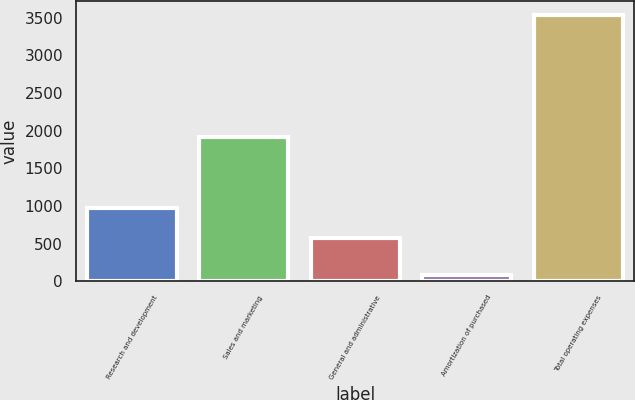Convert chart to OTSL. <chart><loc_0><loc_0><loc_500><loc_500><bar_chart><fcel>Research and development<fcel>Sales and marketing<fcel>General and administrative<fcel>Amortization of purchased<fcel>Total operating expenses<nl><fcel>976<fcel>1910.2<fcel>576.2<fcel>78.5<fcel>3540.9<nl></chart> 